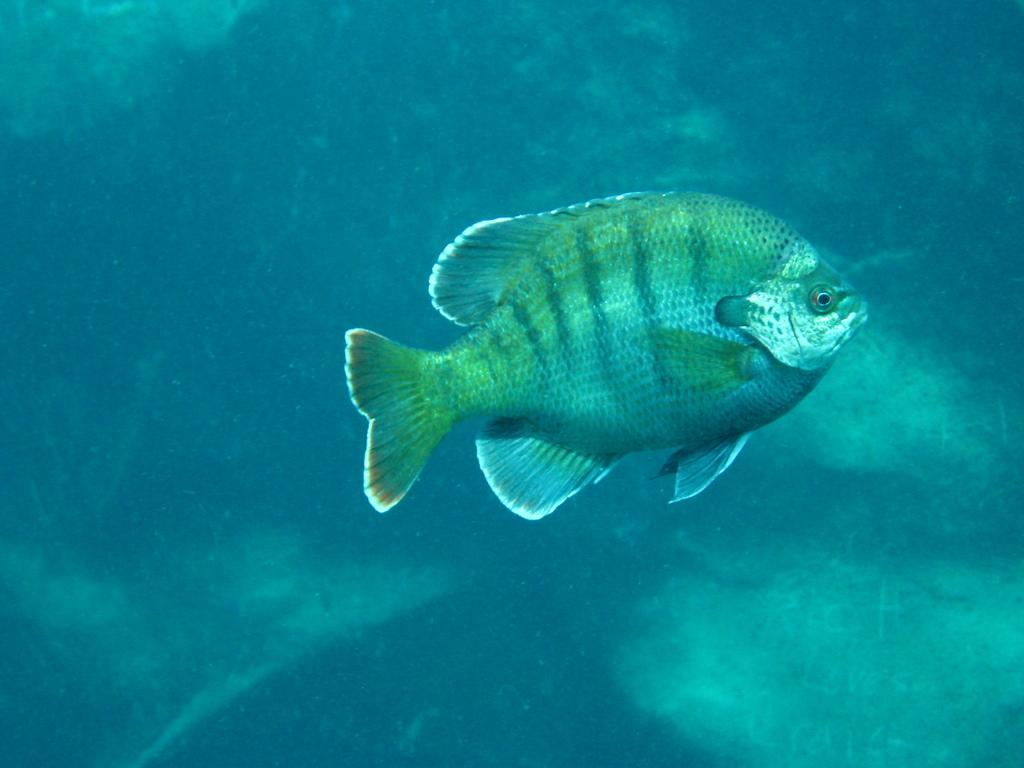What type of animal is in the image? There is a fish in the image. What is the primary element surrounding the fish? There is water visible in the background of the image. What type of trouble can be seen the fish causing in the image? There is no indication of trouble or any specific actions involving the fish in the image. 